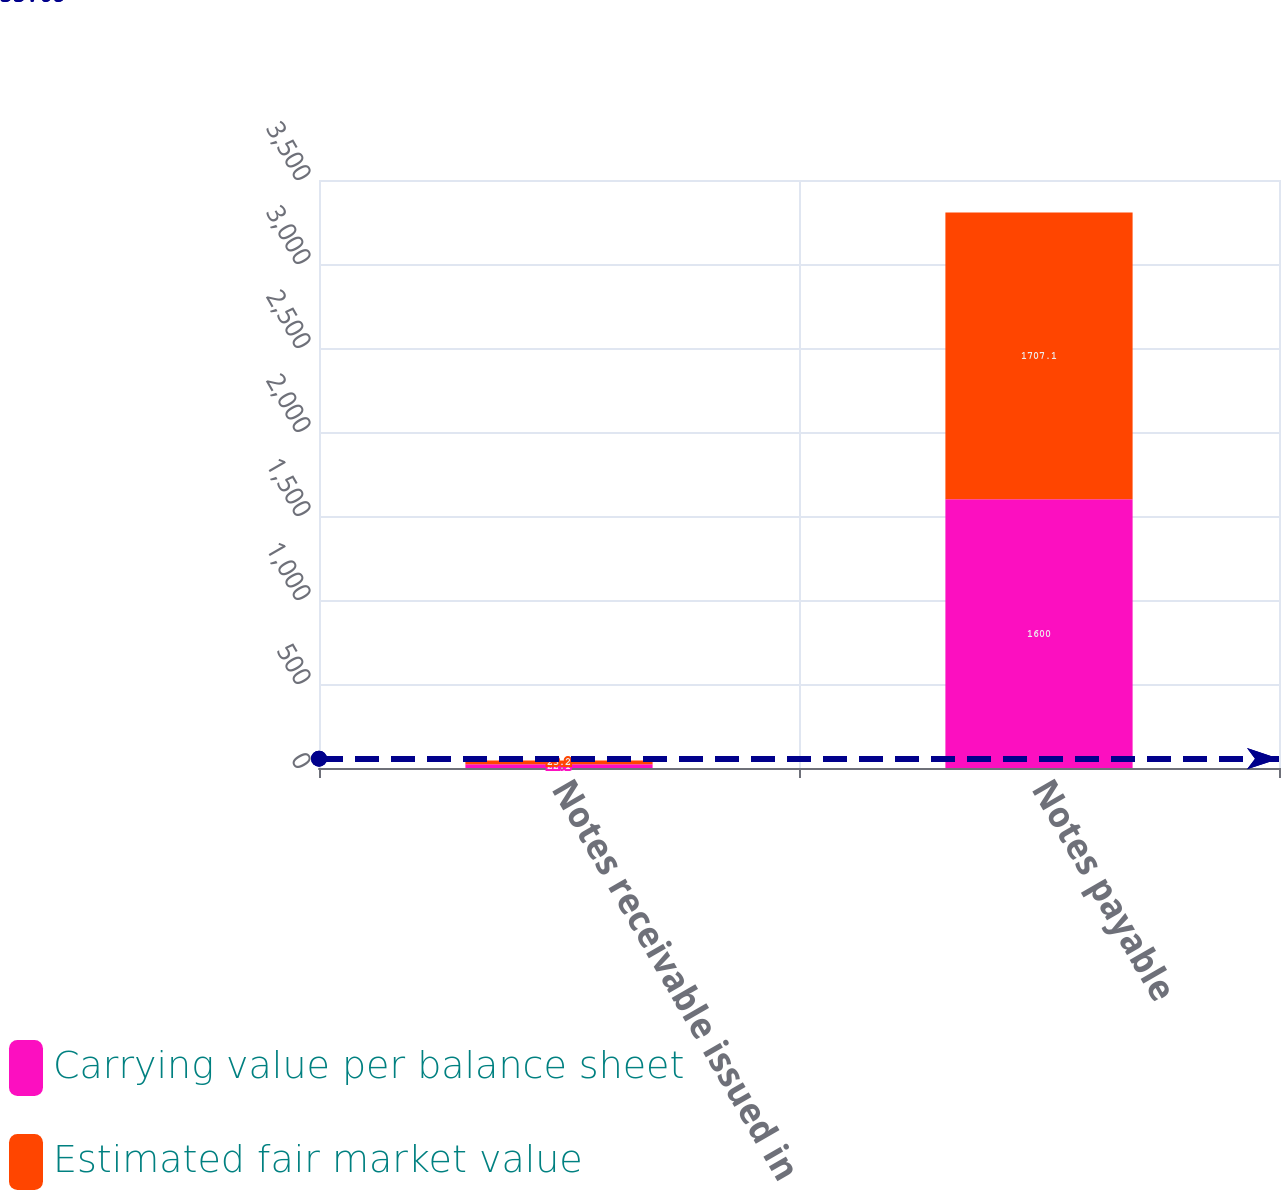<chart> <loc_0><loc_0><loc_500><loc_500><stacked_bar_chart><ecel><fcel>Notes receivable issued in<fcel>Notes payable<nl><fcel>Carrying value per balance sheet<fcel>22.1<fcel>1600<nl><fcel>Estimated fair market value<fcel>23.2<fcel>1707.1<nl></chart> 